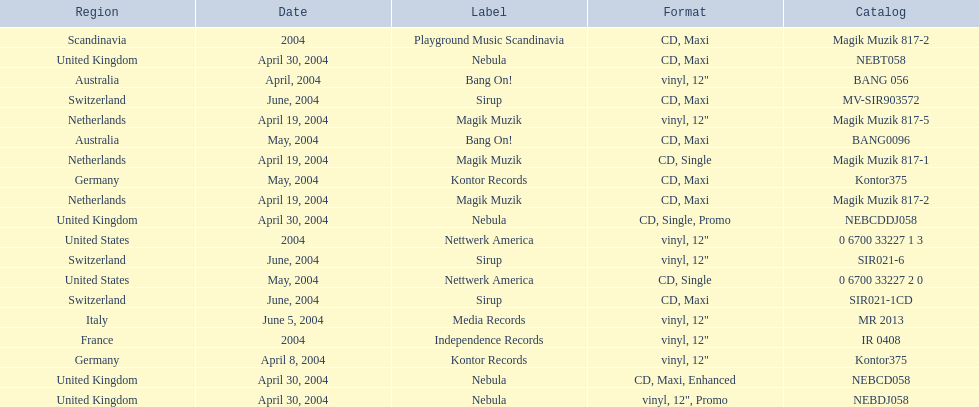What are all of the regions the title was released in? Netherlands, Netherlands, Netherlands, Germany, Germany, Australia, Australia, United Kingdom, United Kingdom, United Kingdom, United Kingdom, Switzerland, Switzerland, Switzerland, United States, United States, France, Italy, Scandinavia. And under which labels were they released? Magik Muzik, Magik Muzik, Magik Muzik, Kontor Records, Kontor Records, Bang On!, Bang On!, Nebula, Nebula, Nebula, Nebula, Sirup, Sirup, Sirup, Nettwerk America, Nettwerk America, Independence Records, Media Records, Playground Music Scandinavia. Which label released the song in france? Independence Records. 